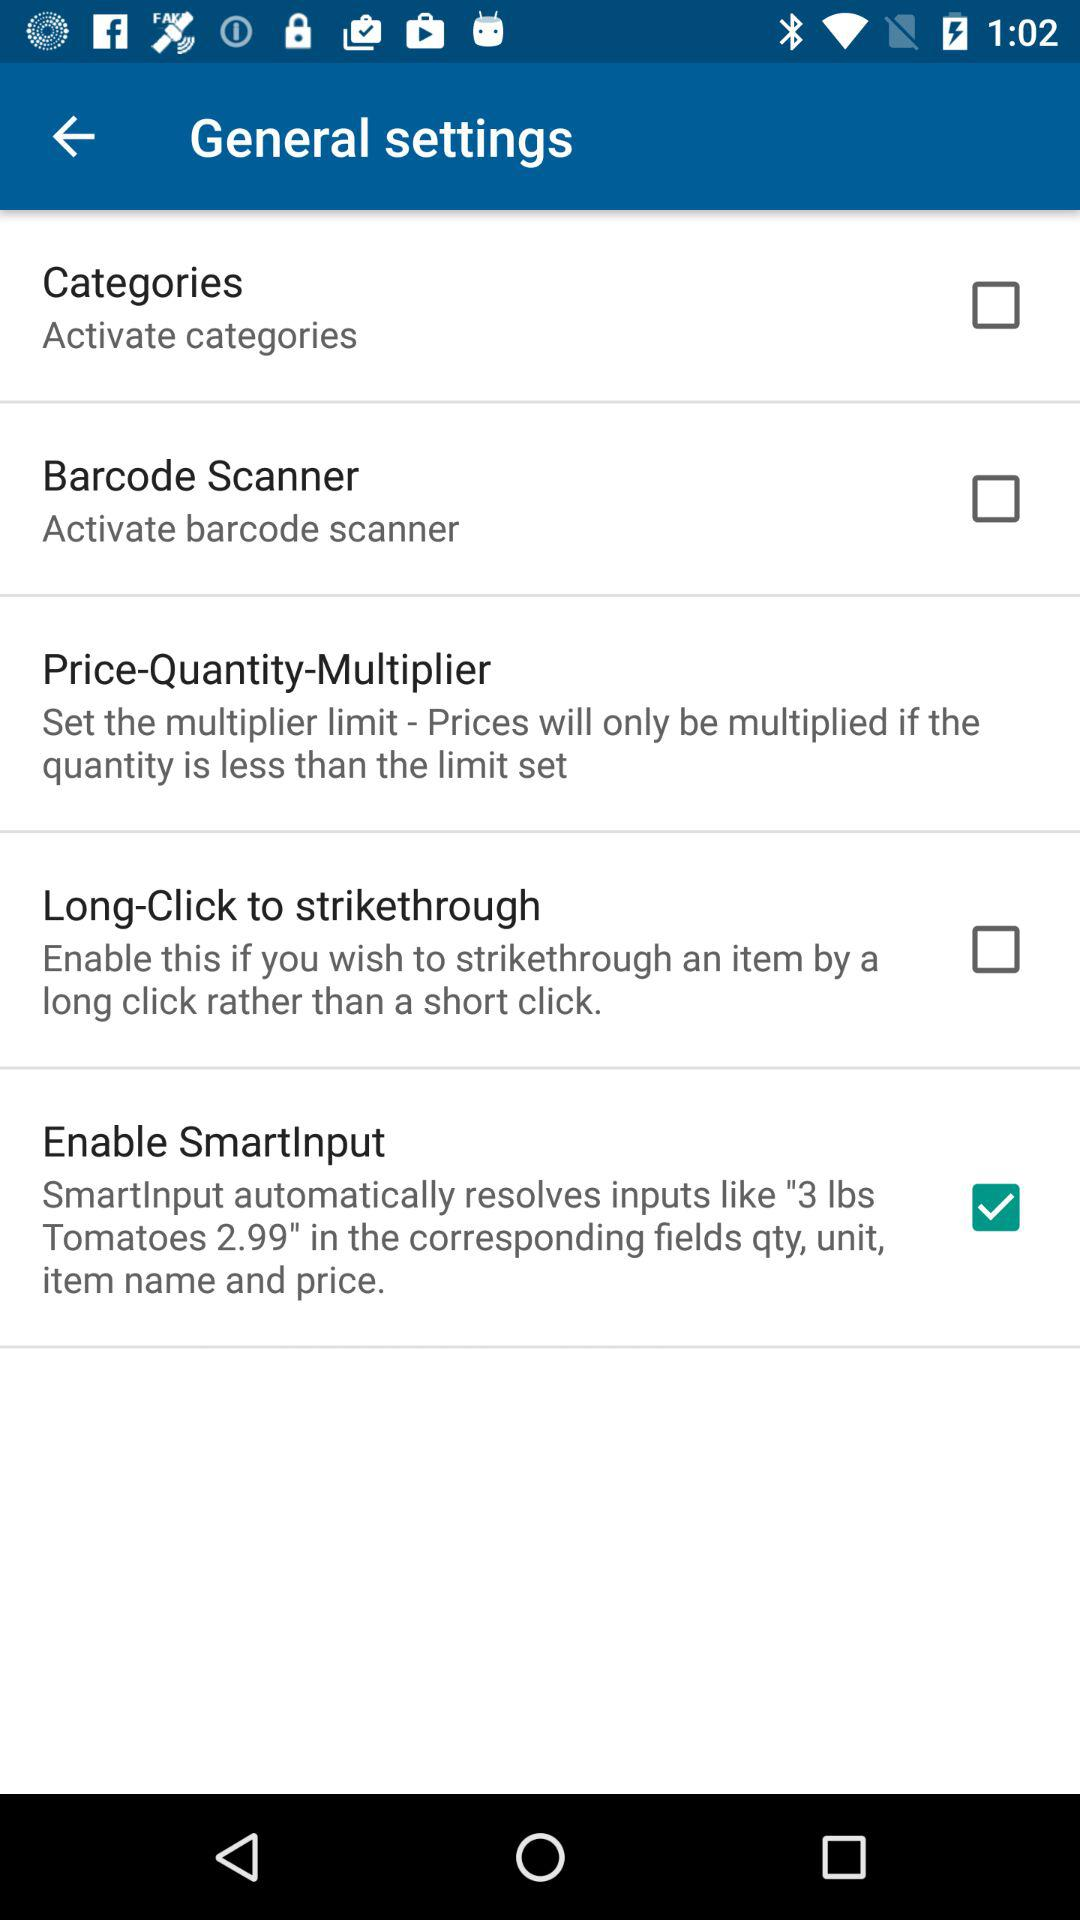What are the corresponding fields in which the "SmartInput" feature resolves inputs automatically? The corresponding fields are qty, unit, item name and price. 